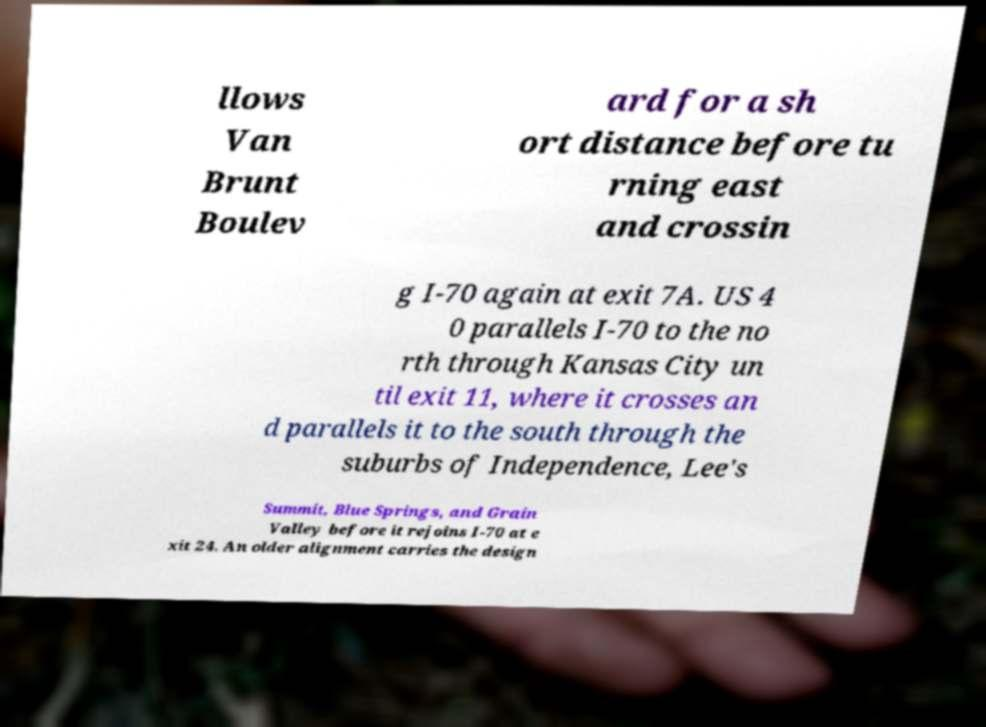Could you assist in decoding the text presented in this image and type it out clearly? llows Van Brunt Boulev ard for a sh ort distance before tu rning east and crossin g I-70 again at exit 7A. US 4 0 parallels I-70 to the no rth through Kansas City un til exit 11, where it crosses an d parallels it to the south through the suburbs of Independence, Lee's Summit, Blue Springs, and Grain Valley before it rejoins I-70 at e xit 24. An older alignment carries the design 